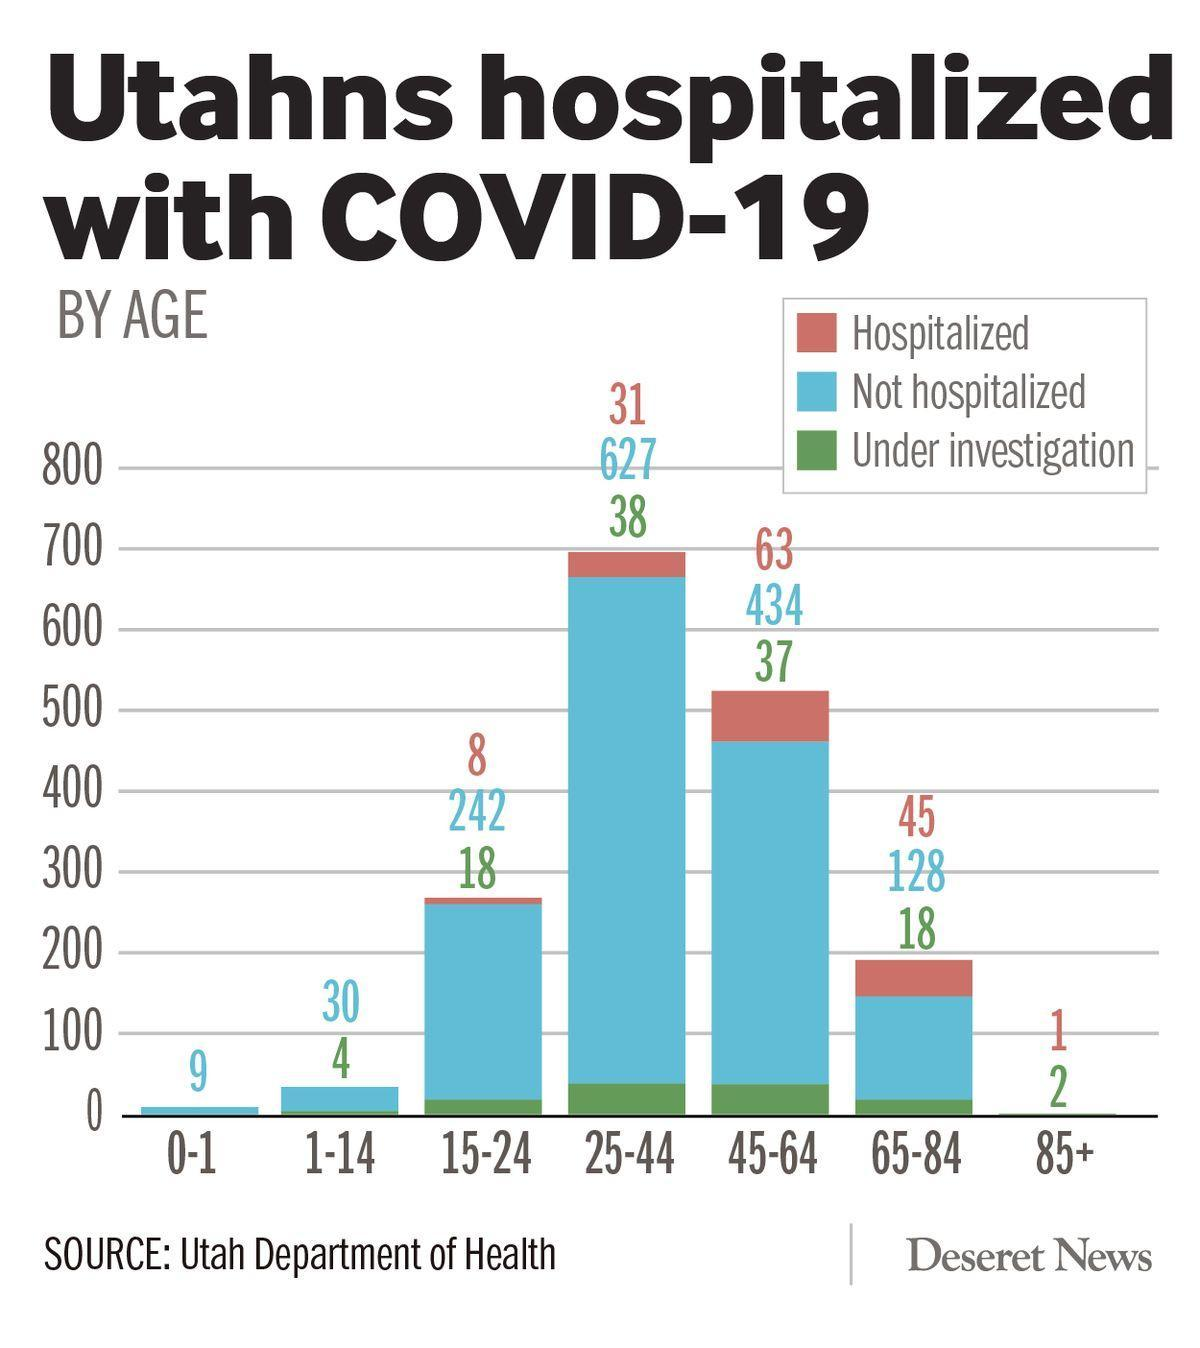What is the total number of hospitalized and not hospitalized in the age group 25-44, taken together?
Answer the question with a short phrase. 658 What is the difference between hospitalized and under investigation in the age group 45-64? 26 What is the difference between hospitalized and not hospitalized in the age group 65-84? 83 What is the total number of hospitalized and not hospitalized in the age group 45-64, taken together? 497 What is the total number of hospitalized and under investigation in the age group 45-64, taken together? 100 